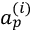Convert formula to latex. <formula><loc_0><loc_0><loc_500><loc_500>a _ { p } ^ { ( i ) }</formula> 